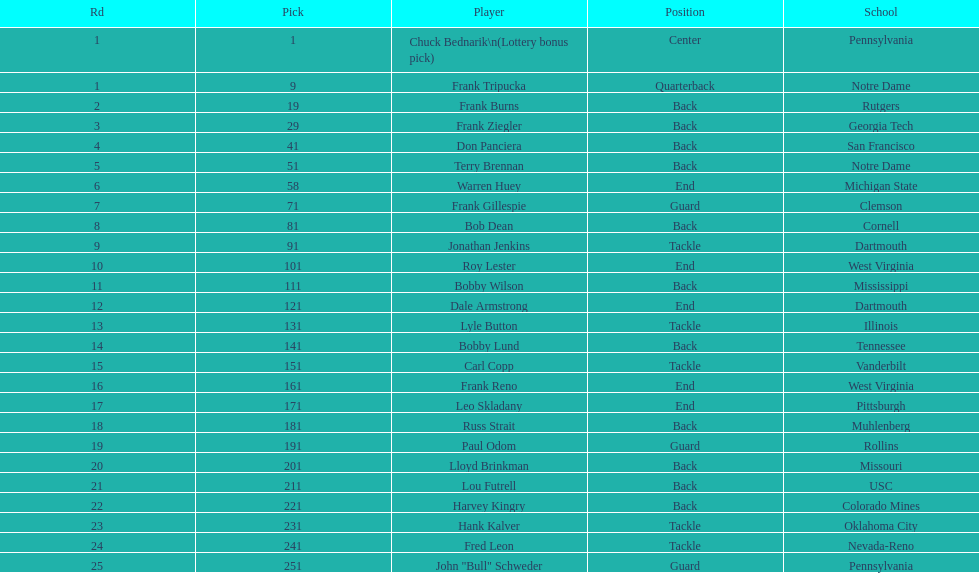After drafting bob dean, who was the next player chosen by the team? Jonathan Jenkins. 